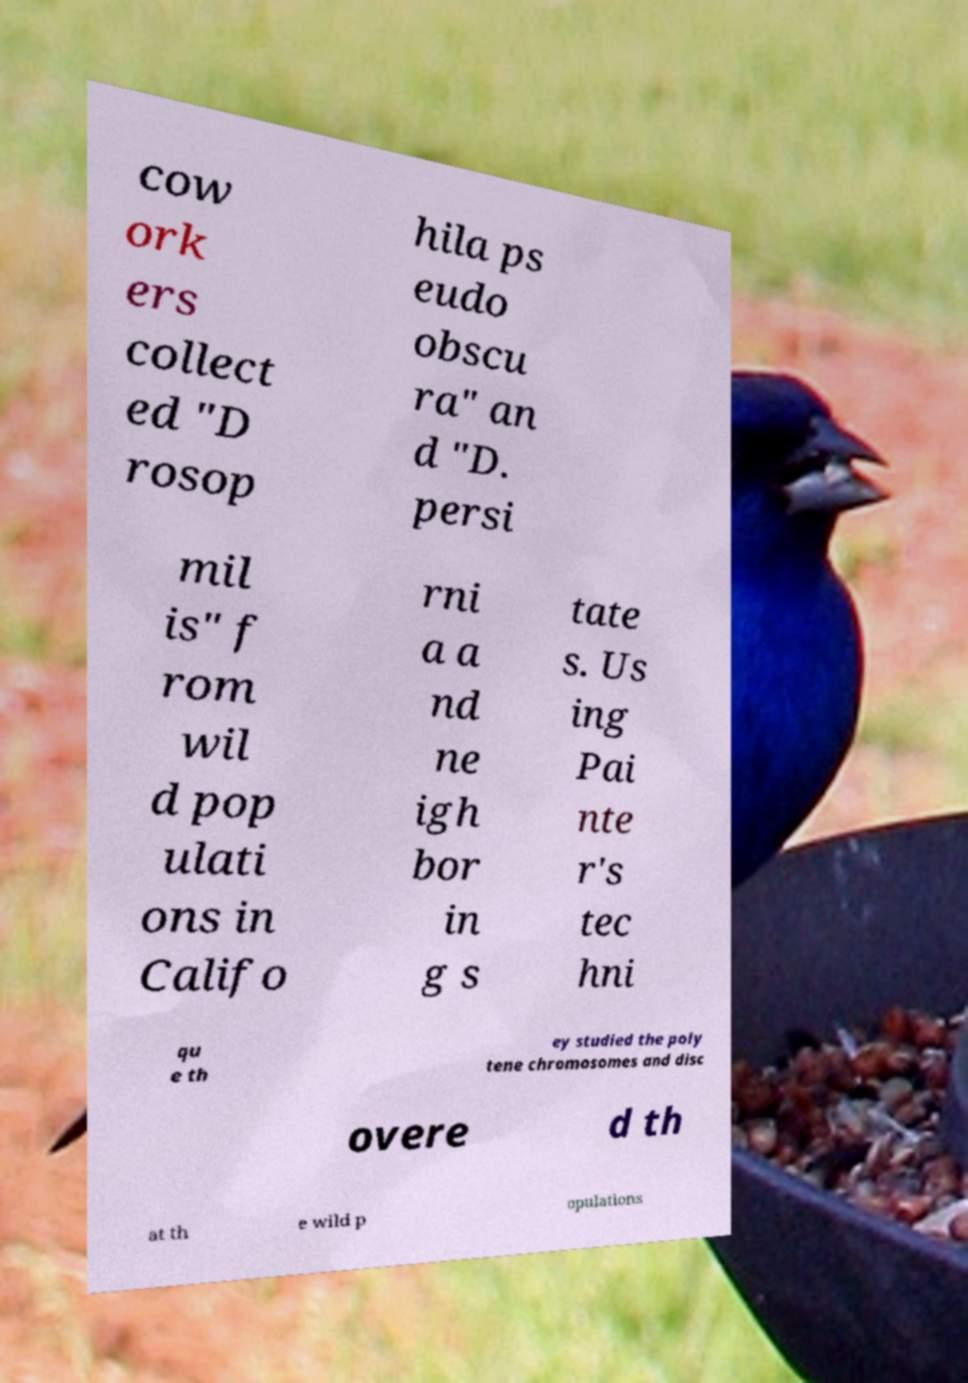Could you assist in decoding the text presented in this image and type it out clearly? cow ork ers collect ed "D rosop hila ps eudo obscu ra" an d "D. persi mil is" f rom wil d pop ulati ons in Califo rni a a nd ne igh bor in g s tate s. Us ing Pai nte r's tec hni qu e th ey studied the poly tene chromosomes and disc overe d th at th e wild p opulations 